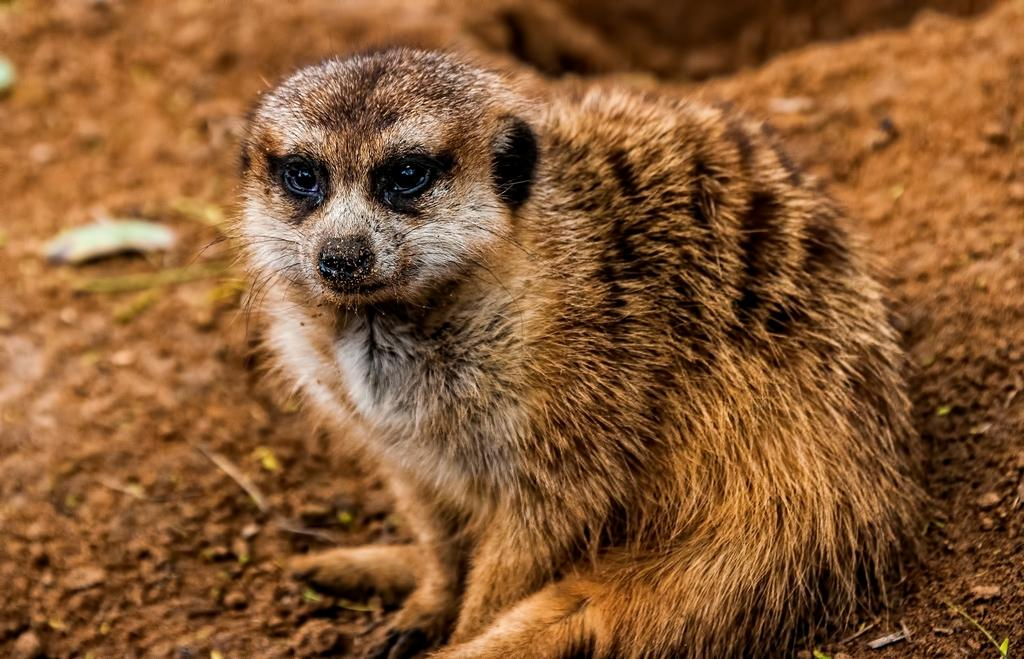What type of creature is present in the image? There is an animal in the image. Can you describe the color pattern of the animal? The animal has black, brown, and white colors. What is the color of the background in the image? The background of the image is brown. What type of music is the animal playing in the image? There is no music or instrument present in the image, so it cannot be determined what type of music the animal might be playing. 